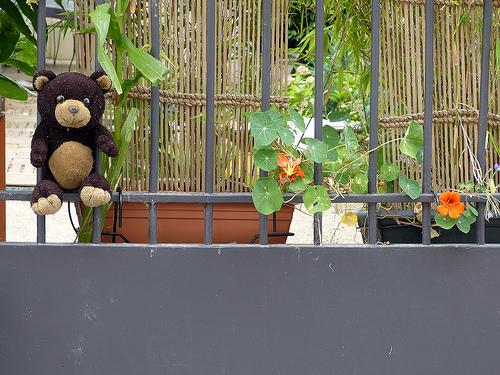What are the colors and distinguishing features of the main object in the image? The teddy bear is brown with a light brown tummy, two eyes, a nose, and distinguishable arms and legs. Mention an action the main subject is performing in the image. The teddy bear is hanging from a fence by its left arm. How does the teddy bear contrast with its surroundings? The brown teddy bear stands out among the gray fence, green leaves, and orange flowers that surround it. What is the atmosphere of the setting presented in the photo? The setting is peaceful and serene with a teddy bear hanging on a fence, surrounded by greenery and orange flowers. Provide a summary of the scene in passive voice. A teddy bear is seen hanging on a fence, near a plant with orange flowers and two flower pots, surrounded by a gray metal fence and a brick colored flower box. In a poetic style, describe the image. Amidst nature's bloom, a teddy bear clings, to the sturdy fence, in a whimsical scene full of green and orange hues, and pots abound. What are the main elements in the photo? There's a teddy bear on the fence, orange flowers on a plant, two flower pots, a gray fence, a bamboo screen, and a brick colored flower box. Can you provide a brief description of the primary object in the image? A teddy bear with a light brown tummy and two eyes is sitting on a gray metal fence, hanging by its left arm. Narrate an imagined backstory for the main subject in the image. A little girl left her teddy bear on the fence to protect her blooming flowers, creating a cozy garden scene for her treasured toy. Using similes, describe the scene in the image. Like a guardian of the garden, the teddy bear hangs upon the fence, watching over the vibrant flowers as they dance in the breeze. Do you see the red brick wall in the background? Though there is a cream brick side wall of the house, there is no mention of a red brick wall in the image. This instruction misleads by introducing a new nonexistent wall color. What material is the wooden fence made from? The fence in the image is metal and painted gray, not wooden. The instruction wrongfully implies the fence is made of wood. The green leaves on the tree are from the spring season. The image mentions green leaves on a tree in the summer season, not spring. The instruction misleads by indicating the wrong season. Can you spot the three flower pots in the picture? The image contains two flower pots, not three. This instruction is misleading by increasing the number of flower pots present. Can you find the gray security wall without bars? The image has a gray security wall with bars, not without. This instruction misleads by asking to look for the absence of bars. The teddy bear has a dark brown tummy. The image features a teddy bear with a light brown tummy, not a dark brown one. The instruction incorrectly describes the bear's tummy color. Can you see the teddy bear standing next to the fence? The teddy bear is hanging or sitting on the fence, not standing next to it. The instruction misleads by describing an incorrect position for the bear. Does the stuffed bear have only one eye? The teddy bear in the image has two eyes, not one. This instruction misleads by implying the bear is missing an eye. Can you spot the pink flowers on the plant? The image has orange flowers, not pink. This instruction is misleading by asking the viewer to look for a nonexistent color. Is the bamboo screen located on the right side of the image? The bamboo screen is located at coordinate X:387 Y:5 in the image, which indicates it is not on the right side. This instruction is misleading by placing the bamboo screen at the wrong side of the image. 